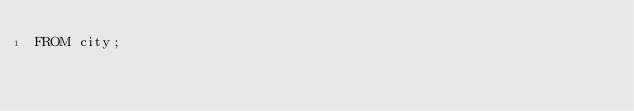Convert code to text. <code><loc_0><loc_0><loc_500><loc_500><_SQL_>FROM city;</code> 